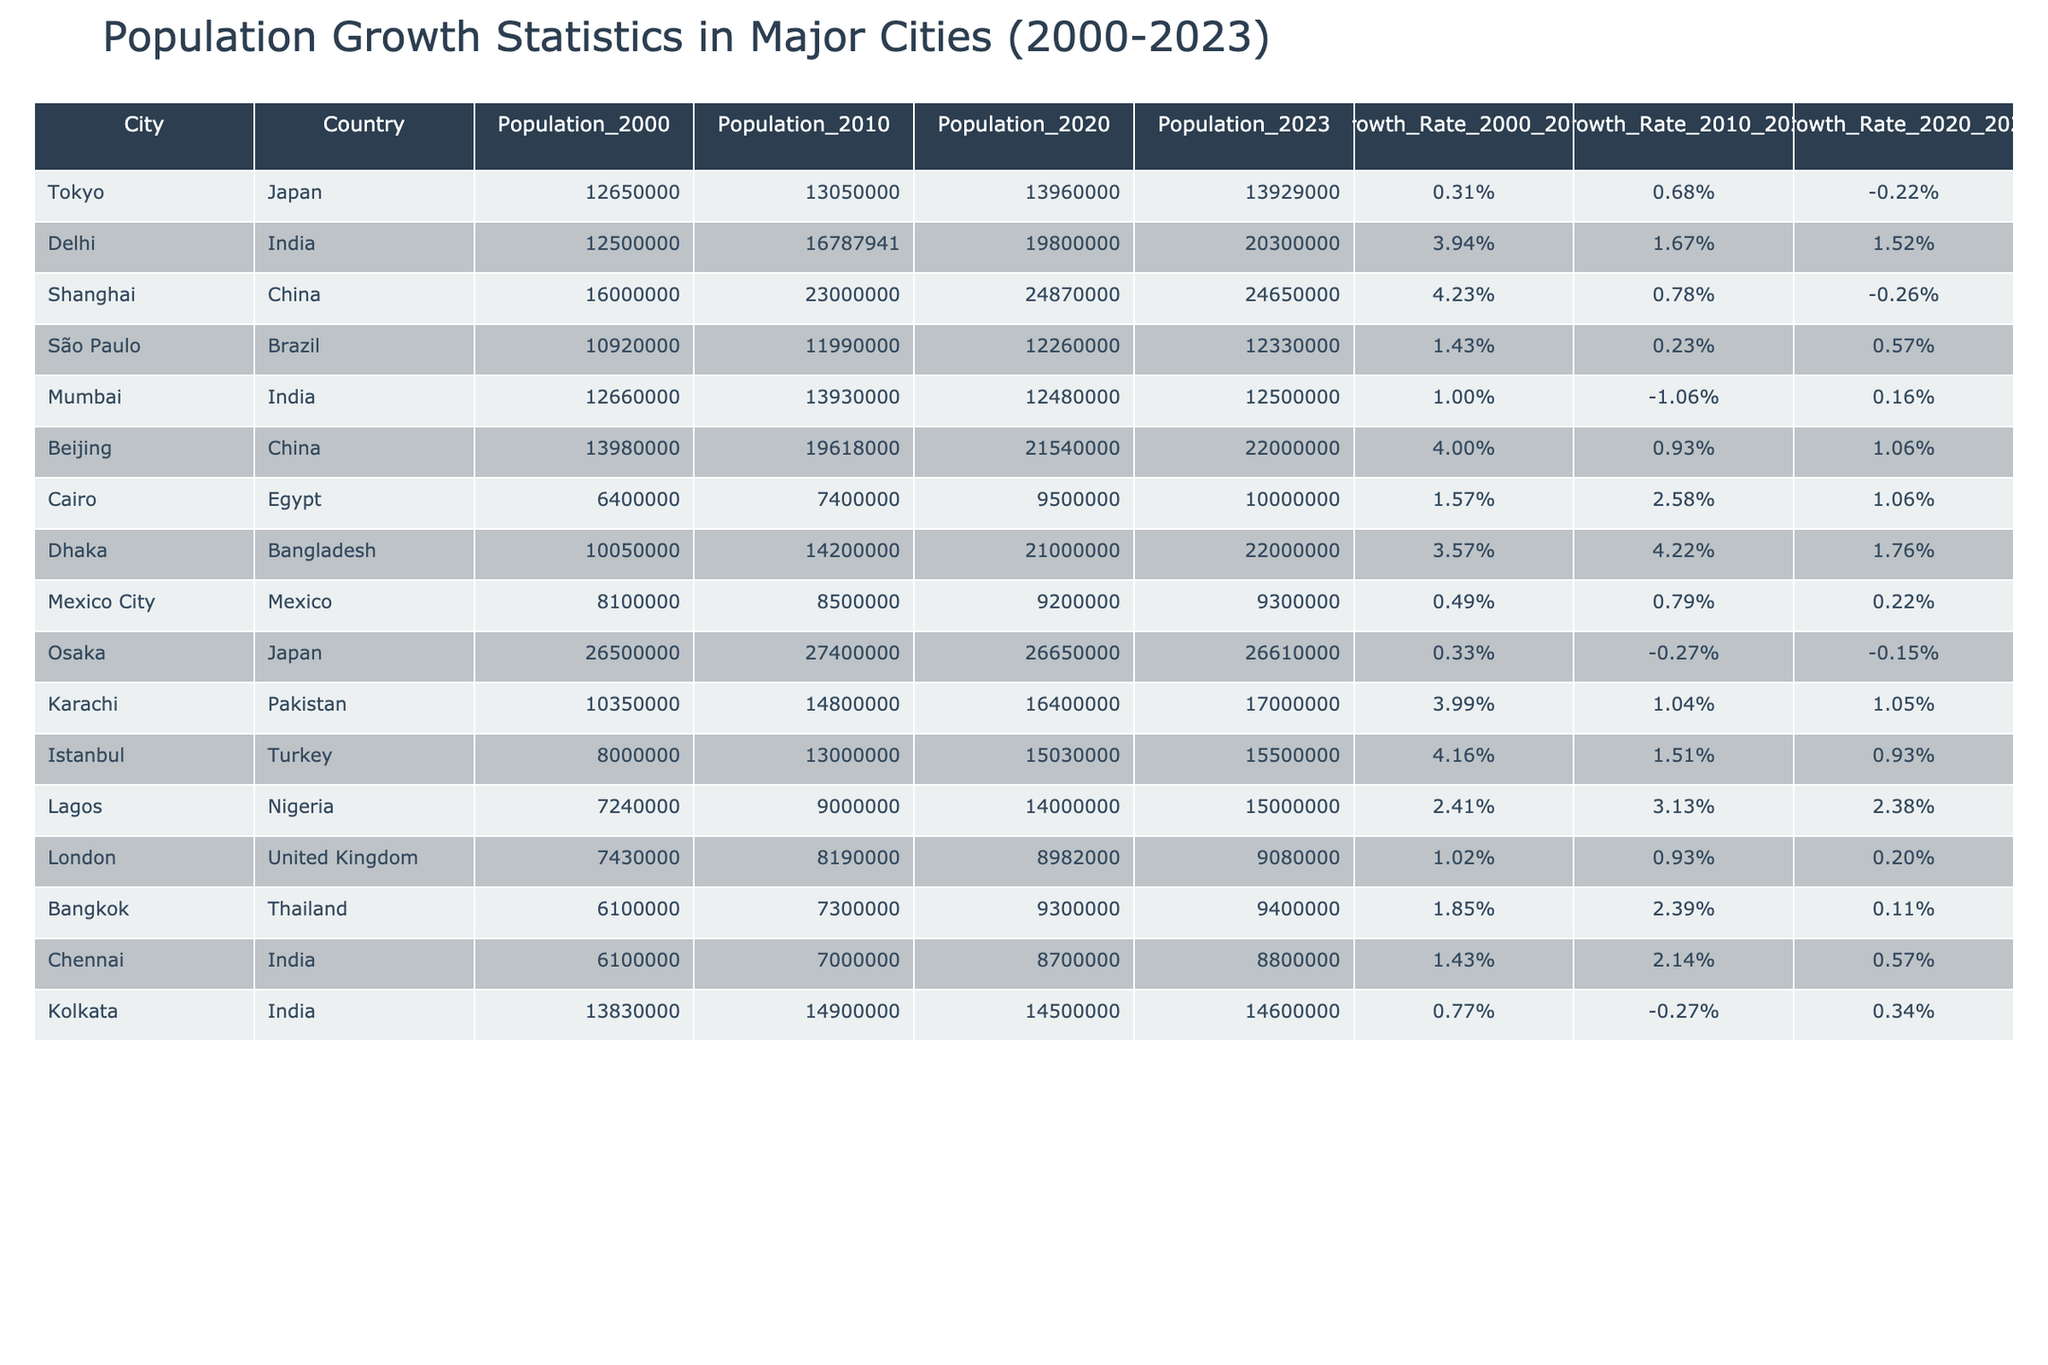What is the population of Delhi in 2023? According to the table, the specified value for Delhi's population in 2023 is directly mentioned in the corresponding row.
Answer: 20,300,000 Which city had the highest population in 2020? Looking at the 2020 population values across all cities listed, Delhi has the highest population at 19,800,000.
Answer: Delhi What was the growth rate of Lagos from 2000 to 2010? The growth rate for Lagos from 2000 to 2010 is explicitly listed in the table as 2.41%.
Answer: 2.41% What is the difference in population between Shanghai in 2010 and in 2023? To find the difference, subtract the 2023 population (24,650,000) from the 2010 population (23,000,000): 24,650,000 - 23,000,000 = 1,650,000.
Answer: 1,650,000 Which two cities had negative growth rates between 2020 and 2023? The cities with negative growth rates during that time period are Tokyo and Shanghai. Checking the last column reveals that Tokyo's growth rate is -0.22% and Shanghai's is -0.26%.
Answer: Tokyo and Shanghai What is the average population growth rate from 2000 to 2023 across all cities? First, sum up all growth rates for the years 2000 to 2010, 2010 to 2020, and 2020 to 2023. Then, divide that total by the number of cities (12). The total sum of rates is: (0.31 + 3.94 + 4.23 + 1.43 + 1.00 + 4.00 + 1.57 + 3.57 + 0.49 + 0.33 + 3.99 + 4.16 + 2.41 + 1.02 + 1.85 + 1.43 + 0.77) / 12 which is approximately 1.54%.
Answer: 1.54% Is Cairo's population in 2020 greater than that of São Paulo in the same year? Checking the table, Cairo's population in 2020 is noted as 9,500,000, while São Paulo's population is 12,260,000. Since 9,500,000 < 12,260,000, the statement is false.
Answer: No Which country has the city with the lowest population in 2000? By examining the population column for the year 2000, we find Lagos with 7,240,000, which is the lowest compared to all other cities listed.
Answer: Nigeria What was the population of Mumbai in 2010 and how much did it change until 2023? Mumbai's population was 13,930,000 in 2010, and in 2023 it is 12,500,000. The change can be calculated as follows: 12,500,000 - 13,930,000 = -1,430,000.
Answer: -1,430,000 Which city shows the highest growth rate from 2010 to 2020? By checking the growth rates for the period from 2010 to 2020, Dhaka shows the highest rate at 4.22%.
Answer: Dhaka 